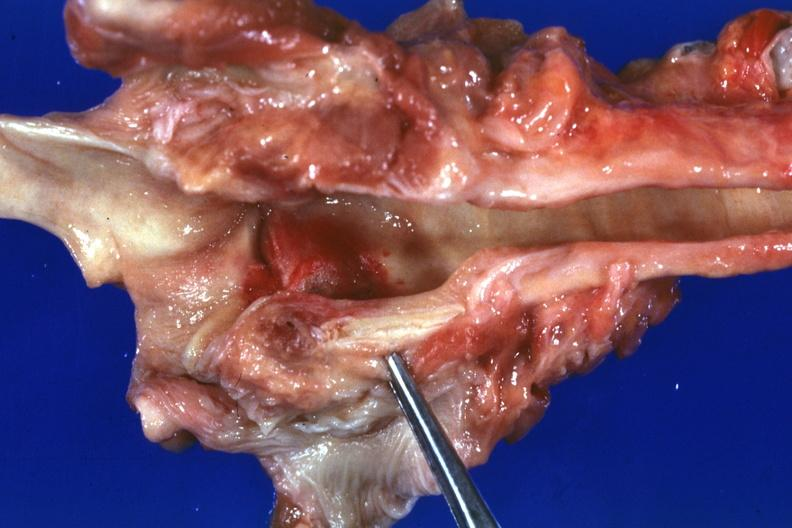what does this image show?
Answer the question using a single word or phrase. Large hemorrhagic lesion about left cord due to tube and candida possibly the portal of entry case of myeloproliferative syndrome with pancytopenia 